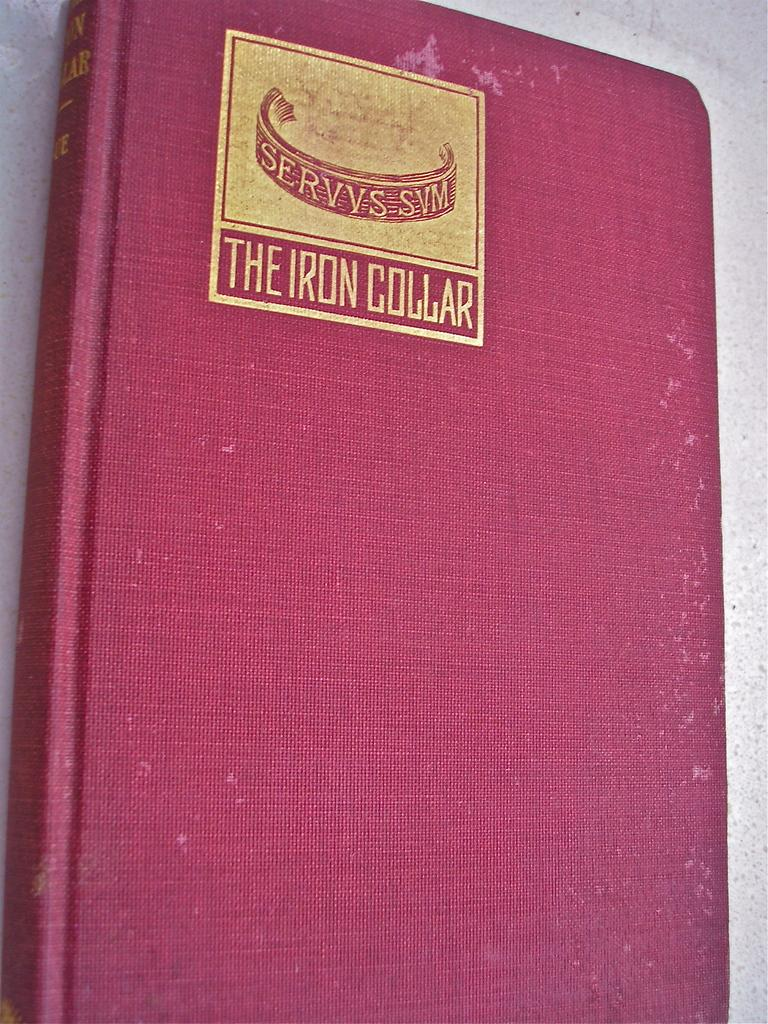<image>
Give a short and clear explanation of the subsequent image. A red book called The Iron Collar in gold. 